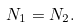Convert formula to latex. <formula><loc_0><loc_0><loc_500><loc_500>N _ { 1 } = N _ { 2 } .</formula> 